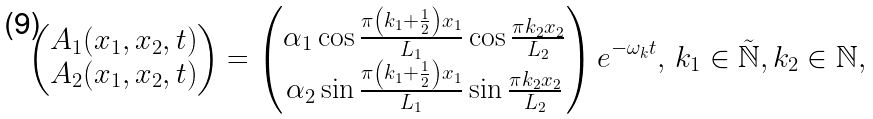Convert formula to latex. <formula><loc_0><loc_0><loc_500><loc_500>\begin{pmatrix} A _ { 1 } ( x _ { 1 } , x _ { 2 } , t ) \\ A _ { 2 } ( x _ { 1 } , x _ { 2 } , t ) \end{pmatrix} = \begin{pmatrix} \alpha _ { 1 } \cos \frac { \pi \left ( k _ { 1 } + \frac { 1 } { 2 } \right ) x _ { 1 } } { L _ { 1 } } \cos \frac { \pi k _ { 2 } x _ { 2 } } { L _ { 2 } } \\ \alpha _ { 2 } \sin \frac { \pi \left ( k _ { 1 } + \frac { 1 } { 2 } \right ) x _ { 1 } } { L _ { 1 } } \sin \frac { \pi k _ { 2 } x _ { 2 } } { L _ { 2 } } \end{pmatrix} e ^ { - \omega _ { k } t } , \, k _ { 1 } \in \tilde { \mathbb { N } } , k _ { 2 } \in \mathbb { N } ,</formula> 